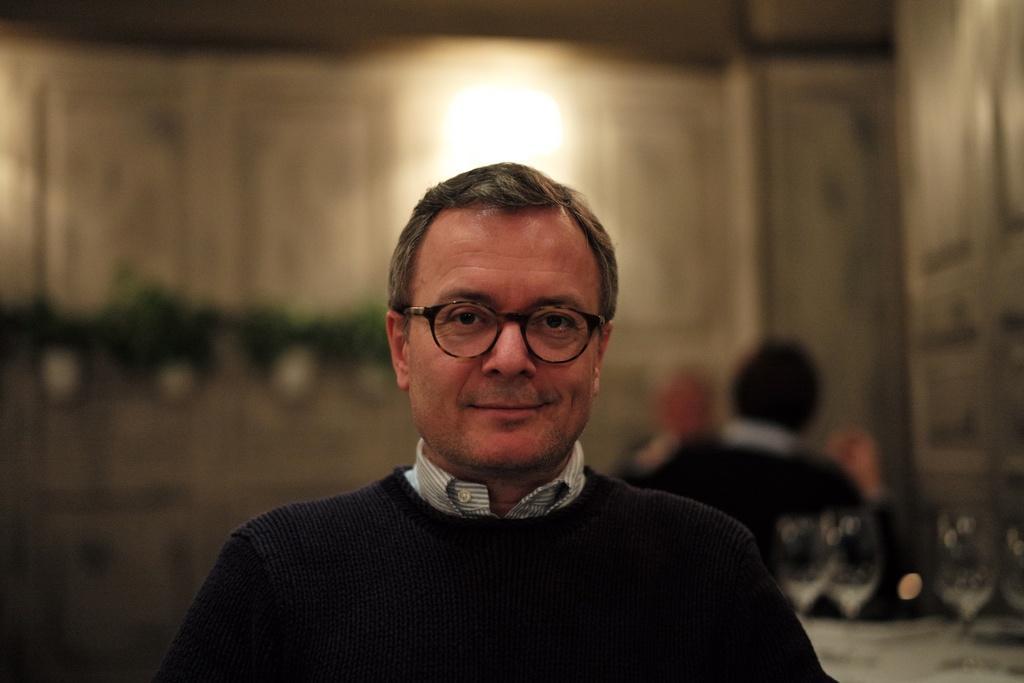How would you summarize this image in a sentence or two? In this image, there is a person on blur background wearing clothes and spectacles. 